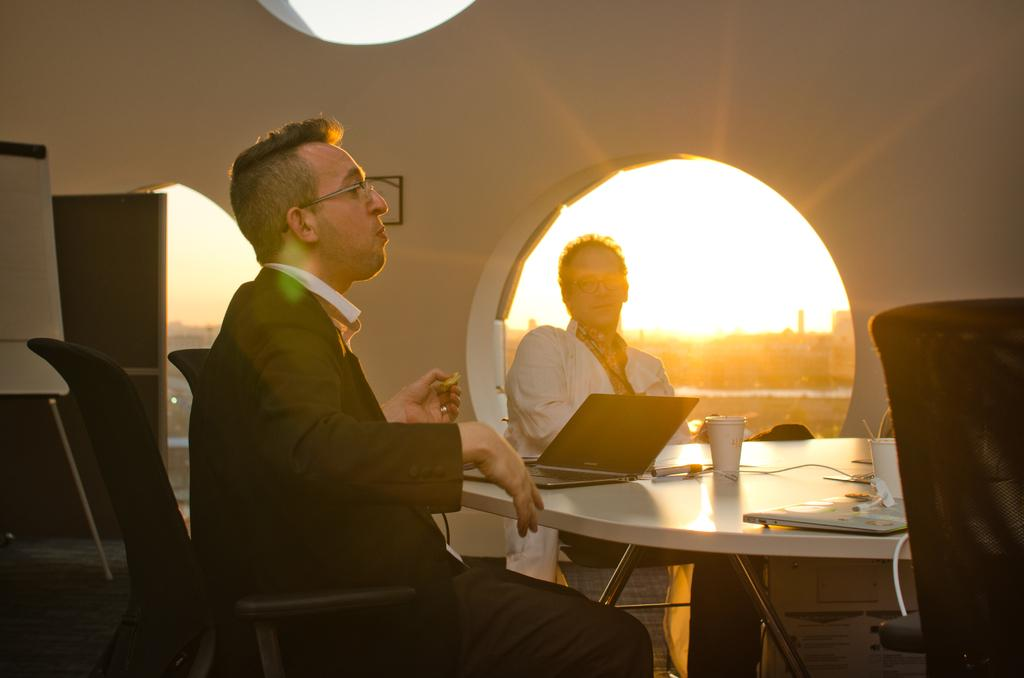How many people are in the image? There are two persons in the image. What are the persons doing in the image? The persons are sitting on chairs. What is in front of the persons? There is a table in front of the persons. What objects can be seen on the table? There is a glass and a laptop on the table. What type of competition is taking place between the persons in the image? There is no competition present in the image; the persons are simply sitting on chairs. How many bikes are visible in the image? There are no bikes visible in the image. 